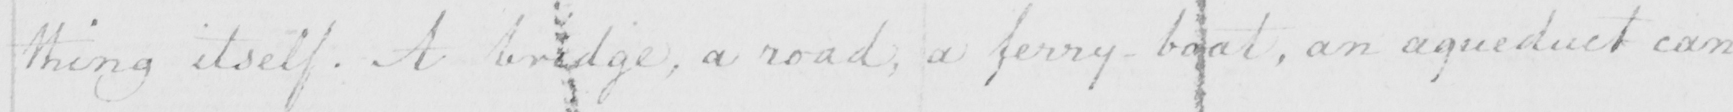What is written in this line of handwriting? thing itself . A bridge , a road , a ferry-boat , an aqueduct can 